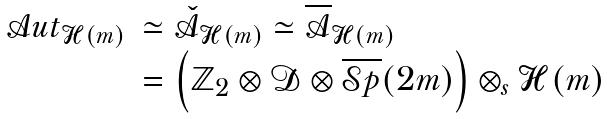<formula> <loc_0><loc_0><loc_500><loc_500>\begin{array} { r l } { \mathcal { A } u t } _ { \mathcal { H } ( m ) } & \simeq { \check { \mathcal { A } } } _ { \mathcal { H } ( m ) } \simeq { \overline { \mathcal { A } } } _ { \mathcal { H } ( m ) } \\ & = \left ( \mathbb { Z } _ { 2 } \otimes \mathcal { D } \otimes \overline { \mathcal { S } p } ( 2 m ) \right ) \otimes _ { s } \mathcal { H } ( m ) \end{array}</formula> 